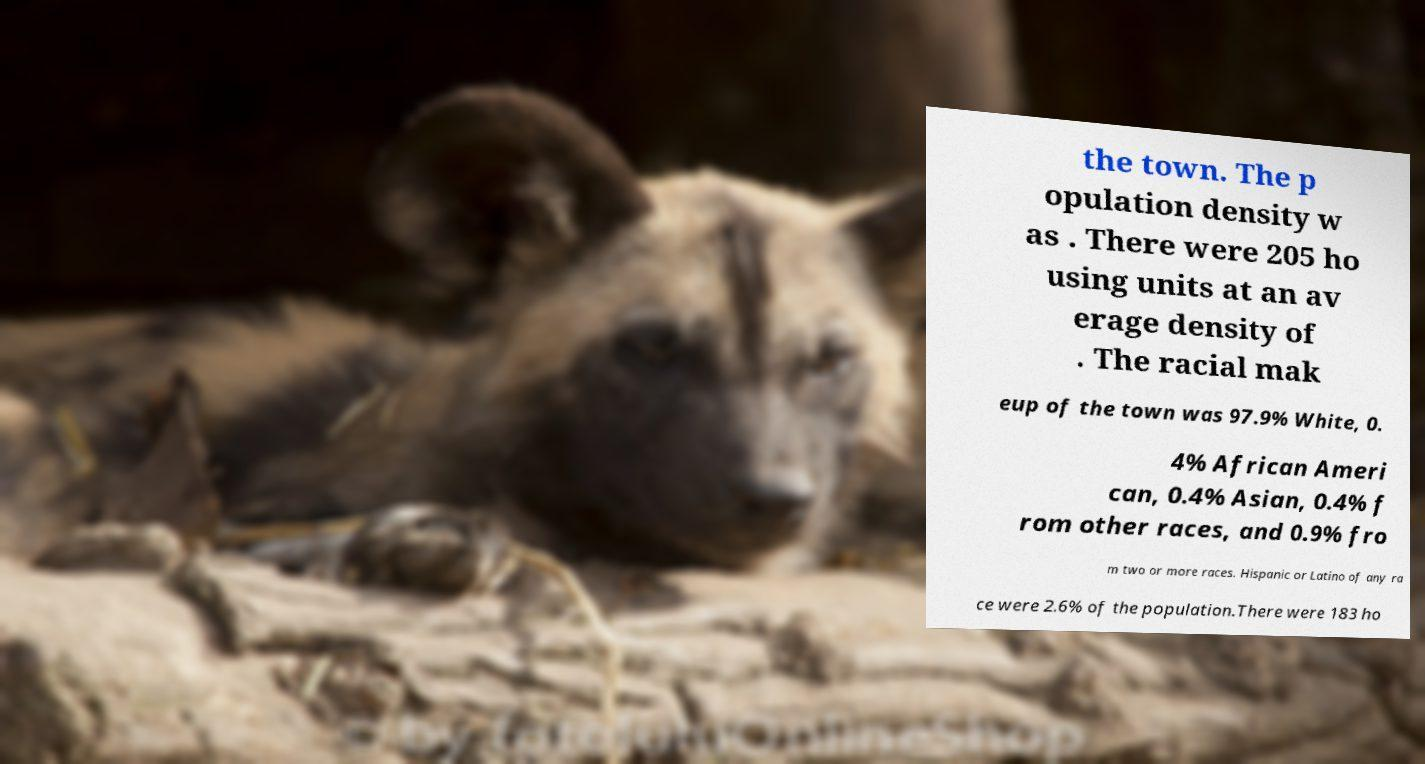I need the written content from this picture converted into text. Can you do that? the town. The p opulation density w as . There were 205 ho using units at an av erage density of . The racial mak eup of the town was 97.9% White, 0. 4% African Ameri can, 0.4% Asian, 0.4% f rom other races, and 0.9% fro m two or more races. Hispanic or Latino of any ra ce were 2.6% of the population.There were 183 ho 